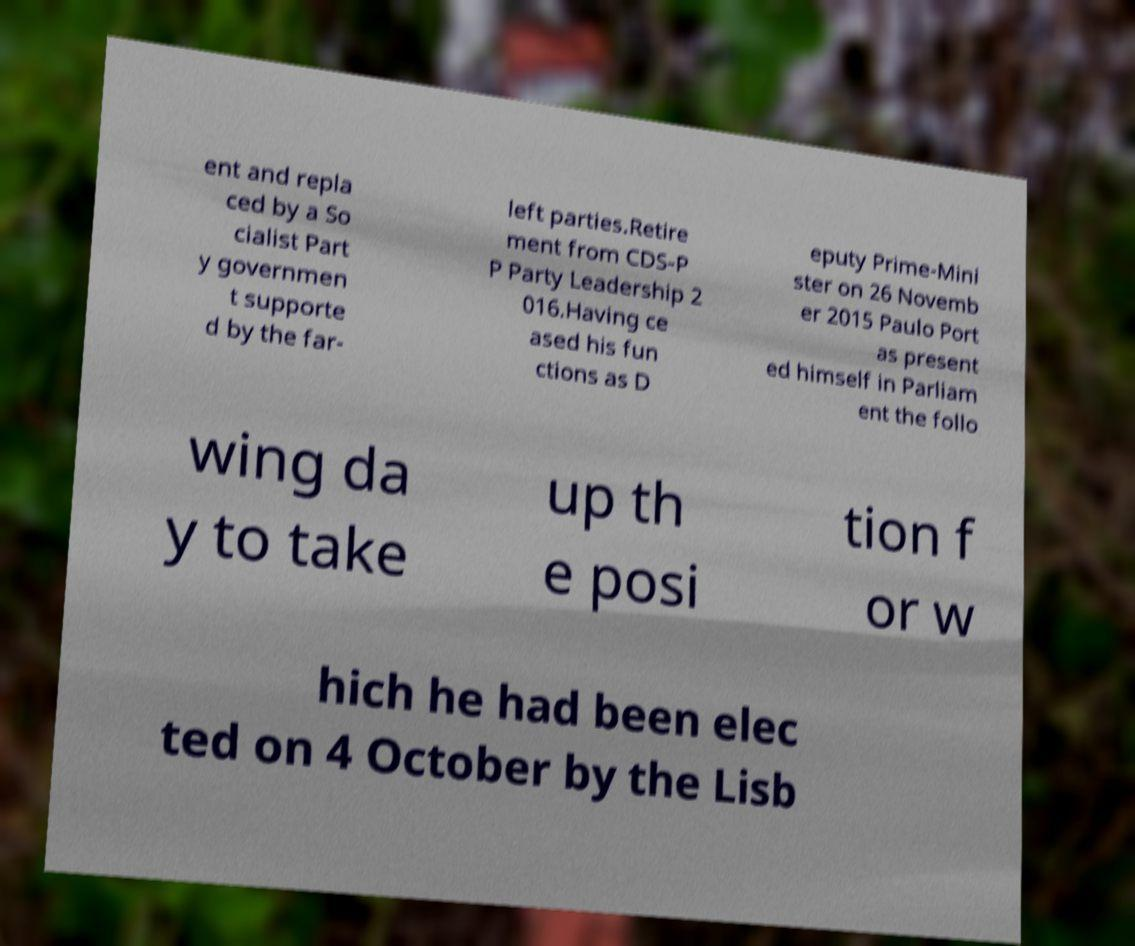For documentation purposes, I need the text within this image transcribed. Could you provide that? ent and repla ced by a So cialist Part y governmen t supporte d by the far- left parties.Retire ment from CDS-P P Party Leadership 2 016.Having ce ased his fun ctions as D eputy Prime-Mini ster on 26 Novemb er 2015 Paulo Port as present ed himself in Parliam ent the follo wing da y to take up th e posi tion f or w hich he had been elec ted on 4 October by the Lisb 